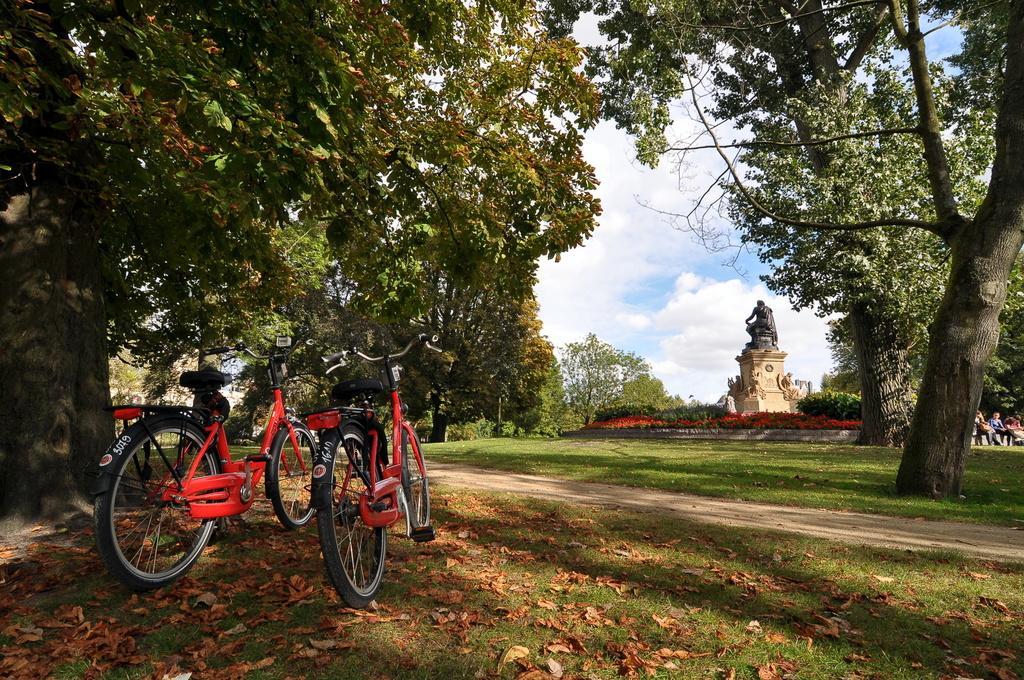Can you describe this image briefly? In this picture there are group of people sitting on the wall and there is a statue and there are trees. On the left side of the image there are bicycles. At the top there is sky and there are clouds. At the bottom there is grass and there are dried leaves and there is ground. 